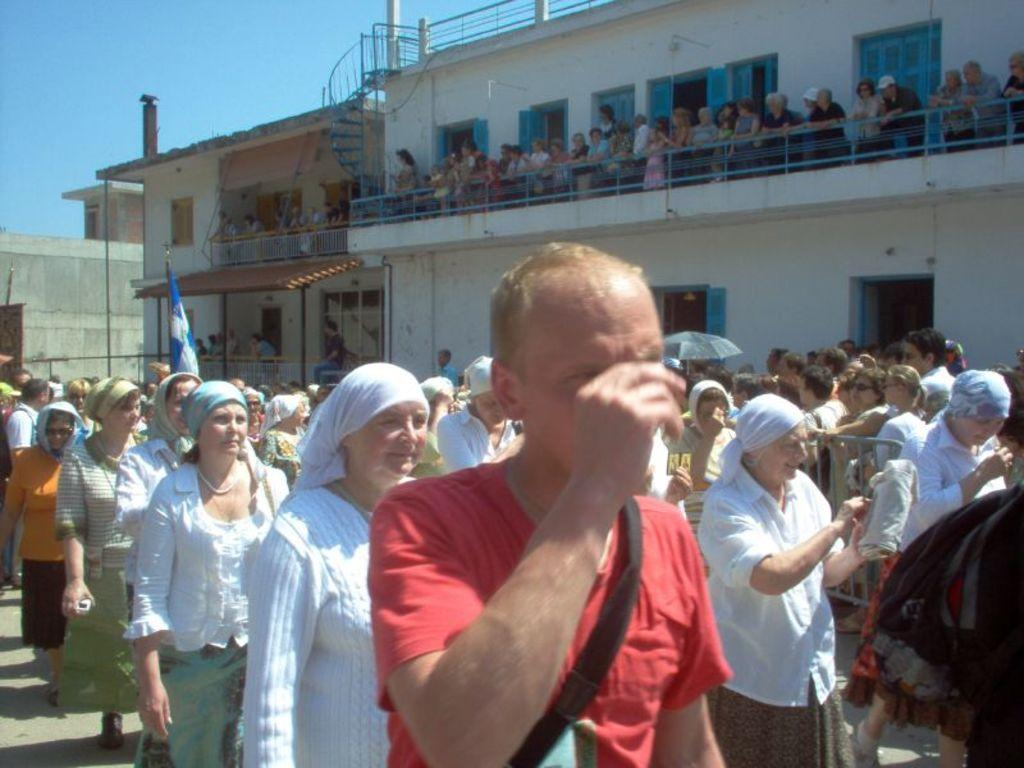What is the main subject of the image? The main subject of the image is a crowd. What objects can be seen in the image besides the crowd? There are umbrellas, a flag, and a building in the image. Can you describe the building in the image? The building has people in it, windows, and steps. What is the color of the sky in the image? The sky is blue in the image. What type of drug is being distributed in the image? There is no mention of any drug in the image; it features a crowd, umbrellas, a flag, and a building. How many mass graves are visible in the image? There are no mass graves present in the image; it focuses on a crowd, umbrellas, a flag, and a building. 